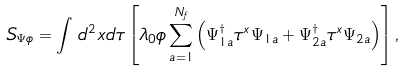<formula> <loc_0><loc_0><loc_500><loc_500>S _ { \Psi \phi } = \int \, d ^ { 2 } x d \tau \left [ \lambda _ { 0 } \phi \sum _ { a = 1 } ^ { N _ { f } } \left ( \Psi _ { 1 a } ^ { \dagger } \tau ^ { x } \Psi _ { 1 a } + \Psi _ { 2 a } ^ { \dagger } \tau ^ { x } \Psi _ { 2 a } \right ) \right ] ,</formula> 